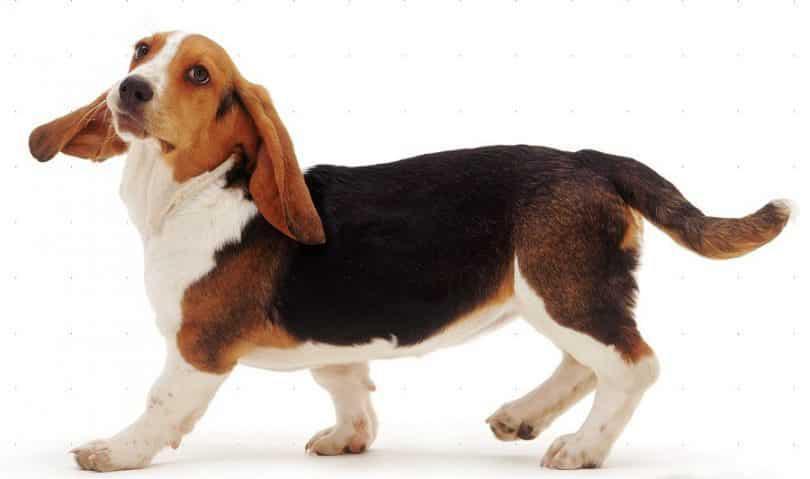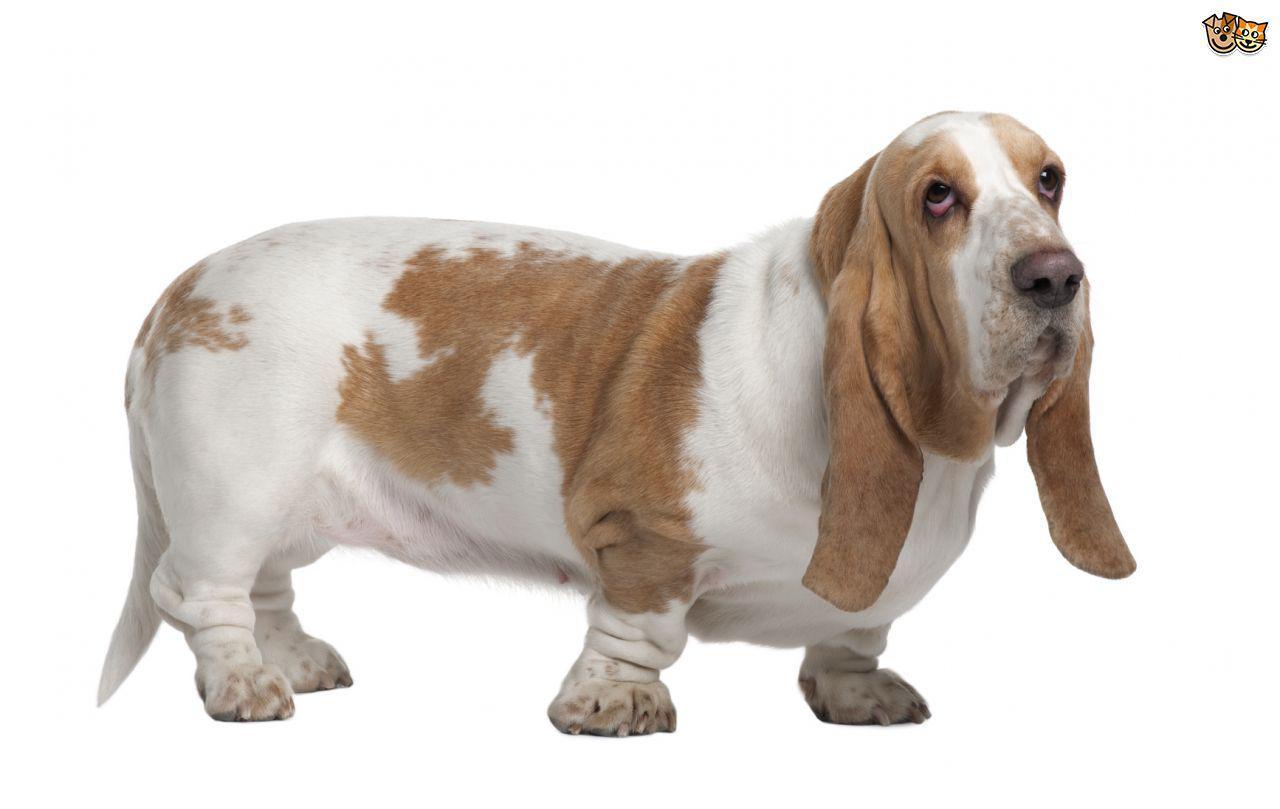The first image is the image on the left, the second image is the image on the right. For the images displayed, is the sentence "One image shows a dog's body in profile, turned toward the left." factually correct? Answer yes or no. Yes. 